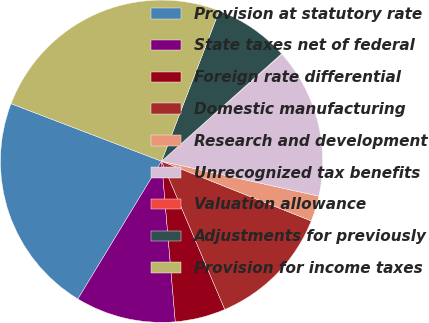<chart> <loc_0><loc_0><loc_500><loc_500><pie_chart><fcel>Provision at statutory rate<fcel>State taxes net of federal<fcel>Foreign rate differential<fcel>Domestic manufacturing<fcel>Research and development<fcel>Unrecognized tax benefits<fcel>Valuation allowance<fcel>Adjustments for previously<fcel>Provision for income taxes<nl><fcel>22.12%<fcel>10.05%<fcel>5.06%<fcel>12.54%<fcel>2.56%<fcel>15.04%<fcel>0.06%<fcel>7.55%<fcel>25.02%<nl></chart> 